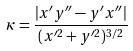Convert formula to latex. <formula><loc_0><loc_0><loc_500><loc_500>\kappa = \frac { | x ^ { \prime } y ^ { \prime \prime } - y ^ { \prime } x ^ { \prime \prime } | } { ( x ^ { \prime 2 } + y ^ { \prime 2 } ) ^ { 3 / 2 } }</formula> 